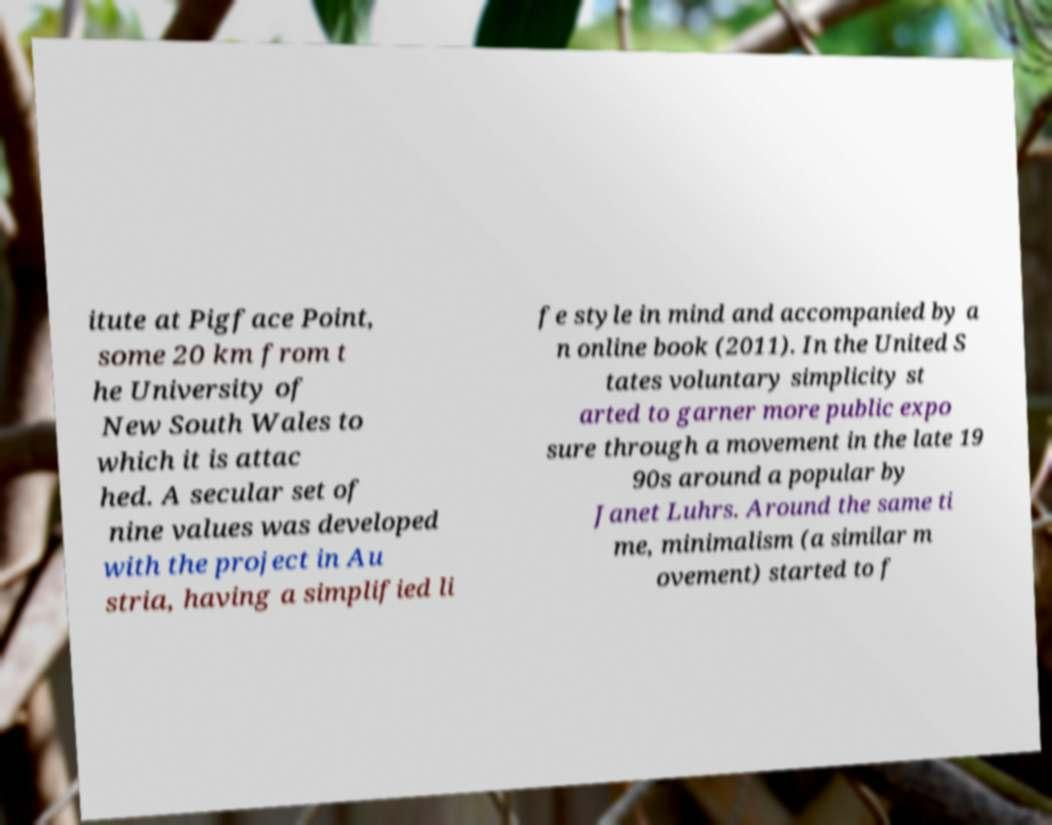For documentation purposes, I need the text within this image transcribed. Could you provide that? itute at Pigface Point, some 20 km from t he University of New South Wales to which it is attac hed. A secular set of nine values was developed with the project in Au stria, having a simplified li fe style in mind and accompanied by a n online book (2011). In the United S tates voluntary simplicity st arted to garner more public expo sure through a movement in the late 19 90s around a popular by Janet Luhrs. Around the same ti me, minimalism (a similar m ovement) started to f 